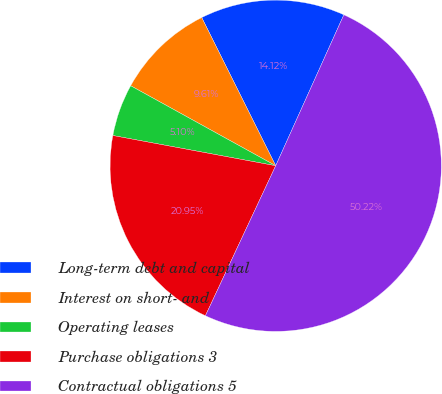Convert chart to OTSL. <chart><loc_0><loc_0><loc_500><loc_500><pie_chart><fcel>Long-term debt and capital<fcel>Interest on short- and<fcel>Operating leases<fcel>Purchase obligations 3<fcel>Contractual obligations 5<nl><fcel>14.12%<fcel>9.61%<fcel>5.1%<fcel>20.95%<fcel>50.23%<nl></chart> 